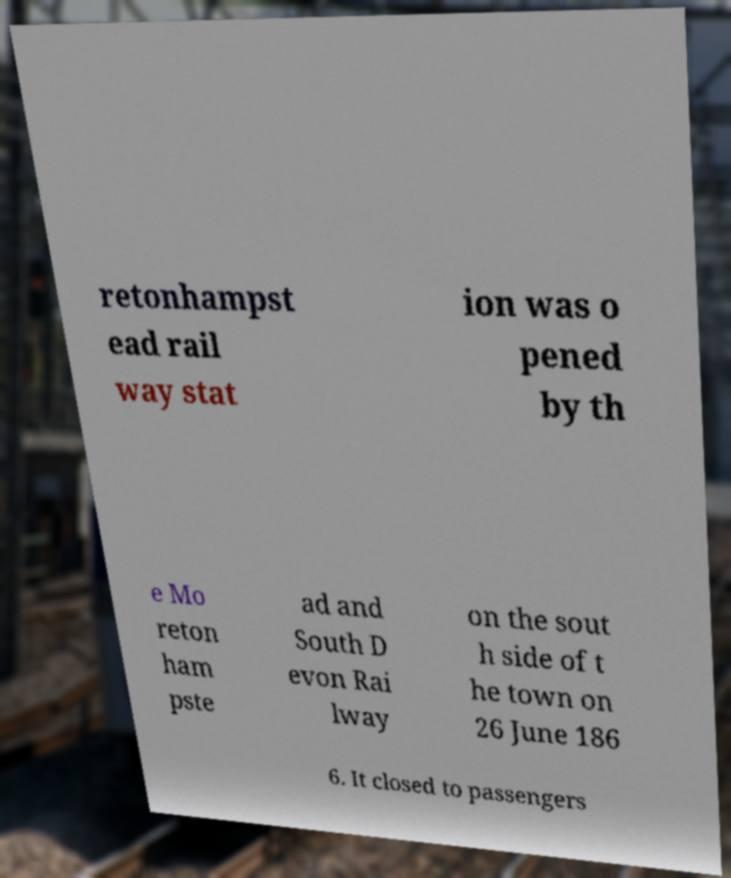Could you assist in decoding the text presented in this image and type it out clearly? retonhampst ead rail way stat ion was o pened by th e Mo reton ham pste ad and South D evon Rai lway on the sout h side of t he town on 26 June 186 6. It closed to passengers 